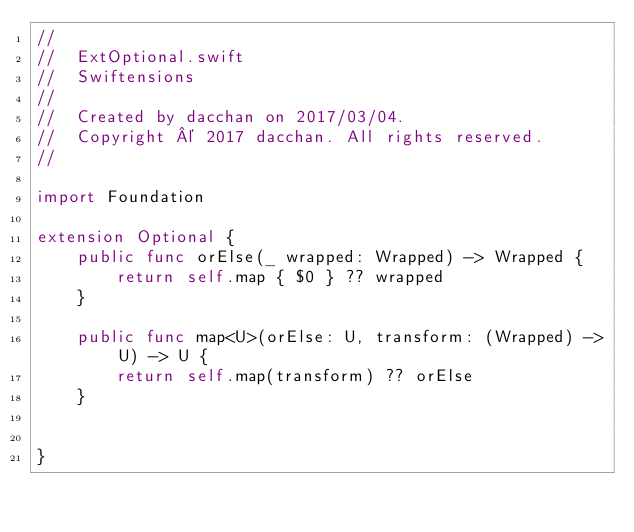<code> <loc_0><loc_0><loc_500><loc_500><_Swift_>//
//  ExtOptional.swift
//  Swiftensions
//
//  Created by dacchan on 2017/03/04.
//  Copyright © 2017 dacchan. All rights reserved.
//

import Foundation

extension Optional {
    public func orElse(_ wrapped: Wrapped) -> Wrapped {
        return self.map { $0 } ?? wrapped
    }

    public func map<U>(orElse: U, transform: (Wrapped) -> U) -> U {
        return self.map(transform) ?? orElse
    }


}
</code> 